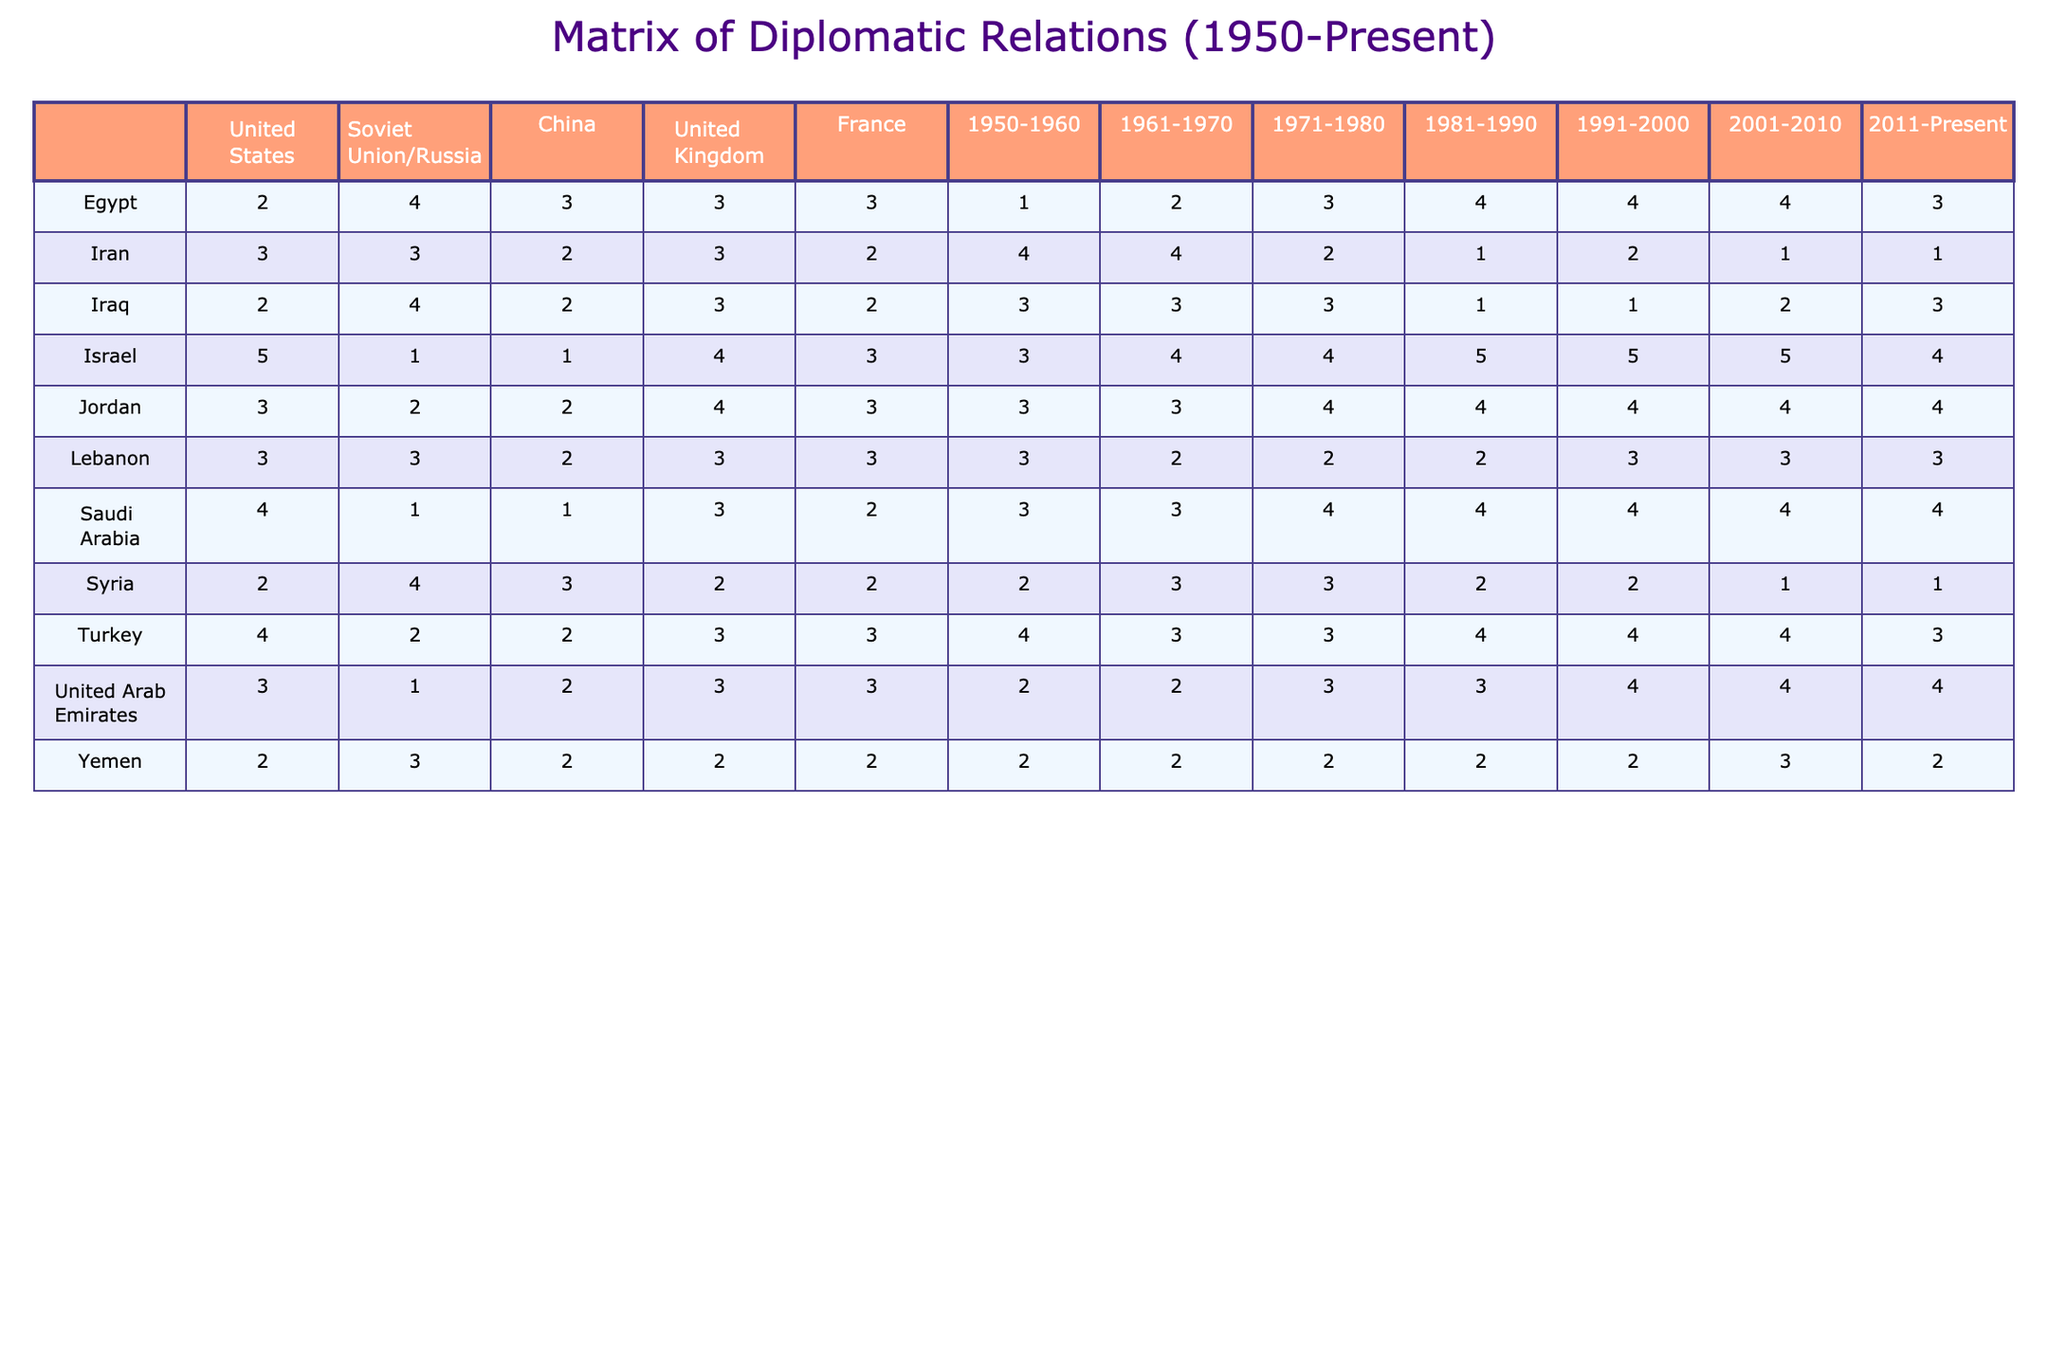What is the diplomatic relationship between Egypt and the United States from 1981 to 1990? The table shows a score of 4 for Egypt's diplomatic relationship with the United States during the period from 1981 to 1990.
Answer: 4 Which country had the highest score in relations with the United Kingdom throughout the entire period? Israel had the highest score of 5 in relations with the United Kingdom in the 1981-1990 and 1991-2000 periods.
Answer: Israel What was the average diplomatic relationship score for Saudi Arabia with all countries from 1950 to 2010? The scores for Saudi Arabia are [4, 1, 1, 3, 2, 3, 3, 4] across those decades. Sum them: 4 + 1 + 1 + 3 + 2 + 3 + 3 + 4 = 21; dividing by the number of periods (8) gives an average of 21/8 = 2.625.
Answer: 2.625 Did Iran's relationship with China improve from 1950 to the present? In 1950-1960, Iran's score with China was 2. In the subsequent periods, Iran's scores were 2 (1961-1970), 2 (1971-1980), and it dropped to 1 in 2001-2010 before remaining at 1 in 2011-Present. There is no improvement, in fact, it declined.
Answer: No What is the difference between Israel’s highest and lowest diplomatic relationship scores from 1950 to the present? The highest score for Israel was 5 (1981-1990, 1991-2000, and 2001-2010) and the lowest score was 1 (with the Soviet Union). Therefore, the difference is 5 - 1 = 4.
Answer: 4 How many countries had a diplomatic relationship score of 4 with the United States in the 1991-2000 period? The countries in the 1991-2000 period with a score of 4 with the United States are Egypt, Israel, Jordan, and Saudi Arabia. There are 4 countries in total.
Answer: 4 Was the diplomatic relationship of Yemen with any country above 3 in the 2001-2010 period? Yemen had scores of 2 with all countries in the 2001-2010 period, so it never exceeded 3.
Answer: No What trend can be identified in Syria’s diplomatic relationships from 1950 to the present? Syria's scores show a decline from 2 (1950-1960) to a consistent lower relationship of 1 in the 2001-2010 and 2011-present periods, indicating a downward trend in diplomatic relations.
Answer: Downward trend Which country had a consistent diplomatic relationship score of 3 with Jordan across most decades? Jordan had a score of 3 with multiple countries, but specifically, its relationship with the United States maintained a score of 3 from 1950 to 2010 across the listed years.
Answer: United States How many countries scored 2 in their relationship with Iraq in the 1981-1990 period? In the 1981-1990 period, Iraq had a score of 2 with China, France, and Iran, totaling 3 countries.
Answer: 3 